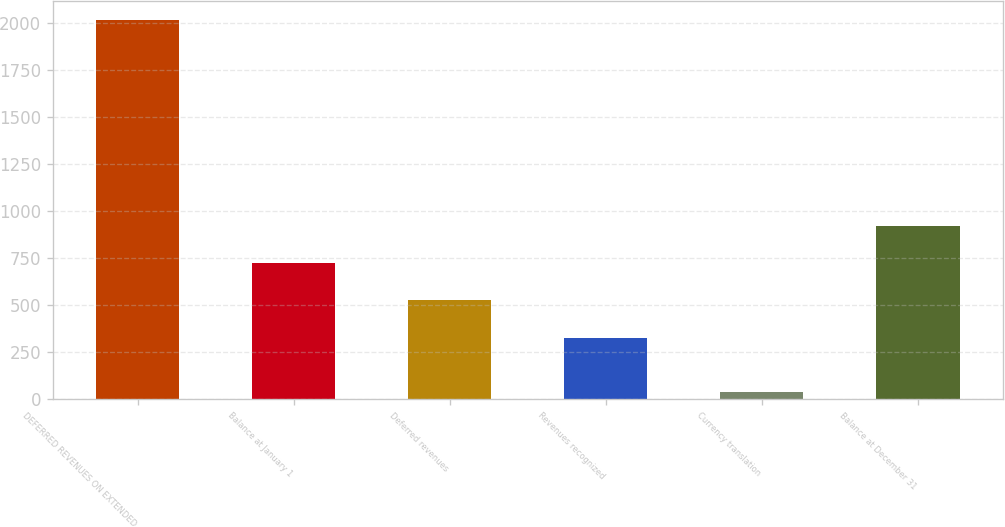<chart> <loc_0><loc_0><loc_500><loc_500><bar_chart><fcel>DEFERRED REVENUES ON EXTENDED<fcel>Balance at January 1<fcel>Deferred revenues<fcel>Revenues recognized<fcel>Currency translation<fcel>Balance at December 31<nl><fcel>2017<fcel>724.24<fcel>526.22<fcel>328.2<fcel>36.8<fcel>922.26<nl></chart> 